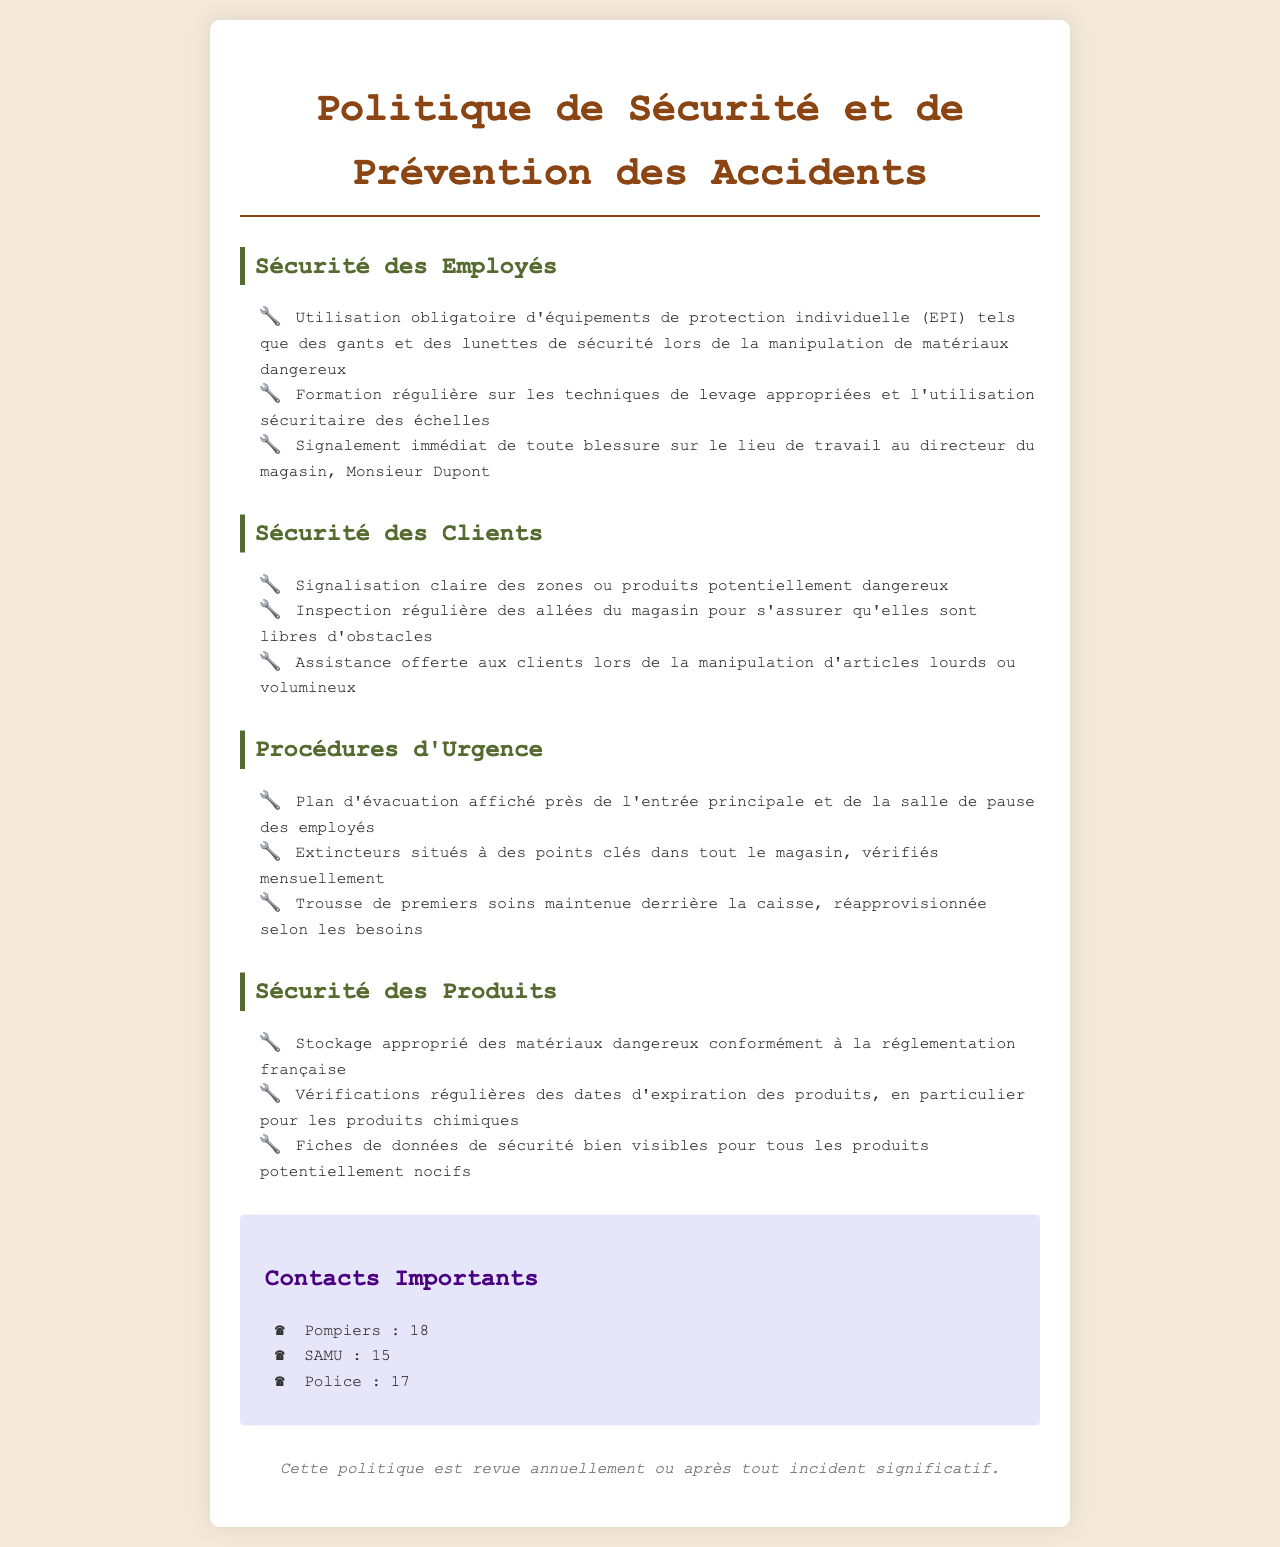What is the title of the document? The title of the document is stated clearly at the top.
Answer: Politique de Sécurité et de Prévention des Accidents Who is the director of the store? The director is mentioned in relation to employee safety procedures.
Answer: Monsieur Dupont What is the emergency number for the police? This number is found under the contacts section of the document.
Answer: 17 How often are the fire extinguishers checked? This information is provided in the emergency procedures section.
Answer: Mensuellement What should employees wear when handling hazardous materials? The document specifies mandatory protective equipment for safety.
Answer: Équipements de protection individuelle What type of assistance is offered to clients? The document outlines the support provided to customers regarding heavy items.
Answer: Assistance offerte What is the purpose of safety data sheets? Safety data sheets are intended for the safety of potentially harmful products.
Answer: Produits potentiellement nocifs Where is the first aid kit located? This information can be found in the emergency procedures section.
Answer: Derrière la caisse 